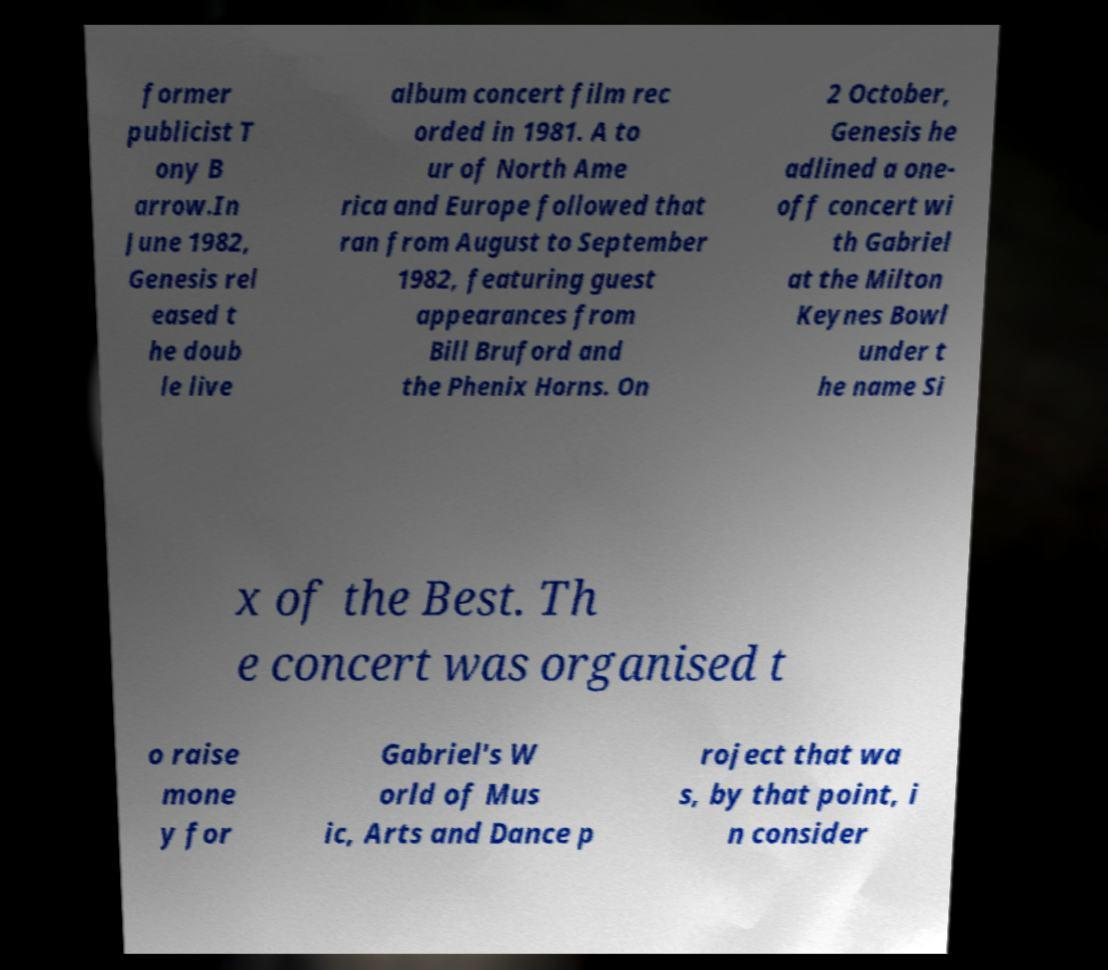Could you extract and type out the text from this image? former publicist T ony B arrow.In June 1982, Genesis rel eased t he doub le live album concert film rec orded in 1981. A to ur of North Ame rica and Europe followed that ran from August to September 1982, featuring guest appearances from Bill Bruford and the Phenix Horns. On 2 October, Genesis he adlined a one- off concert wi th Gabriel at the Milton Keynes Bowl under t he name Si x of the Best. Th e concert was organised t o raise mone y for Gabriel's W orld of Mus ic, Arts and Dance p roject that wa s, by that point, i n consider 